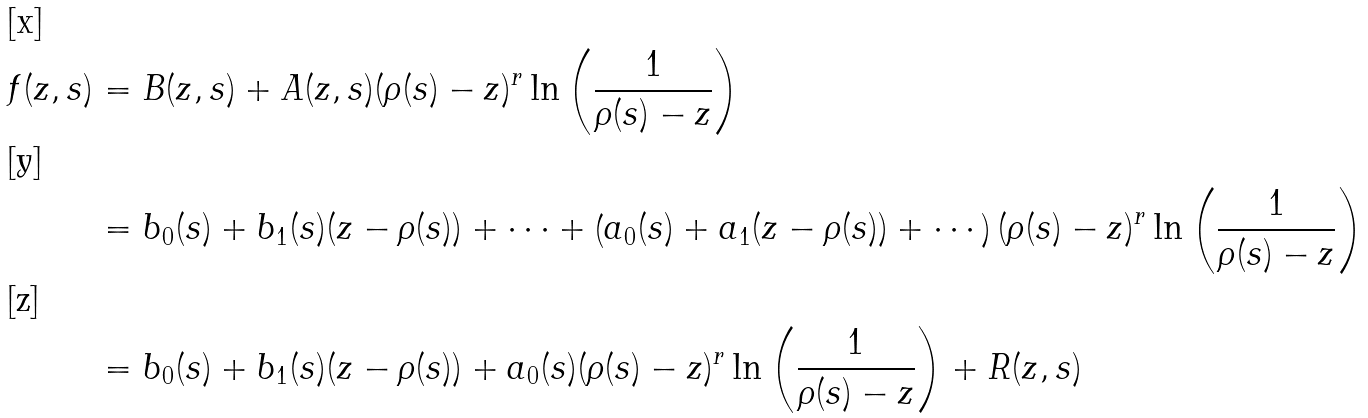Convert formula to latex. <formula><loc_0><loc_0><loc_500><loc_500>f ( z , s ) & = B ( z , s ) + A ( z , s ) ( \rho ( s ) - z ) ^ { r } \ln \left ( \frac { 1 } { \rho ( s ) - z } \right ) \\ & = b _ { 0 } ( s ) + b _ { 1 } ( s ) ( z - \rho ( s ) ) + \cdots + \left ( a _ { 0 } ( s ) + a _ { 1 } ( z - \rho ( s ) ) + \cdots \right ) ( \rho ( s ) - z ) ^ { r } \ln \left ( \frac { 1 } { \rho ( s ) - z } \right ) \\ & = b _ { 0 } ( s ) + b _ { 1 } ( s ) ( z - \rho ( s ) ) + a _ { 0 } ( s ) ( \rho ( s ) - z ) ^ { r } \ln \left ( \frac { 1 } { \rho ( s ) - z } \right ) + R ( z , s )</formula> 